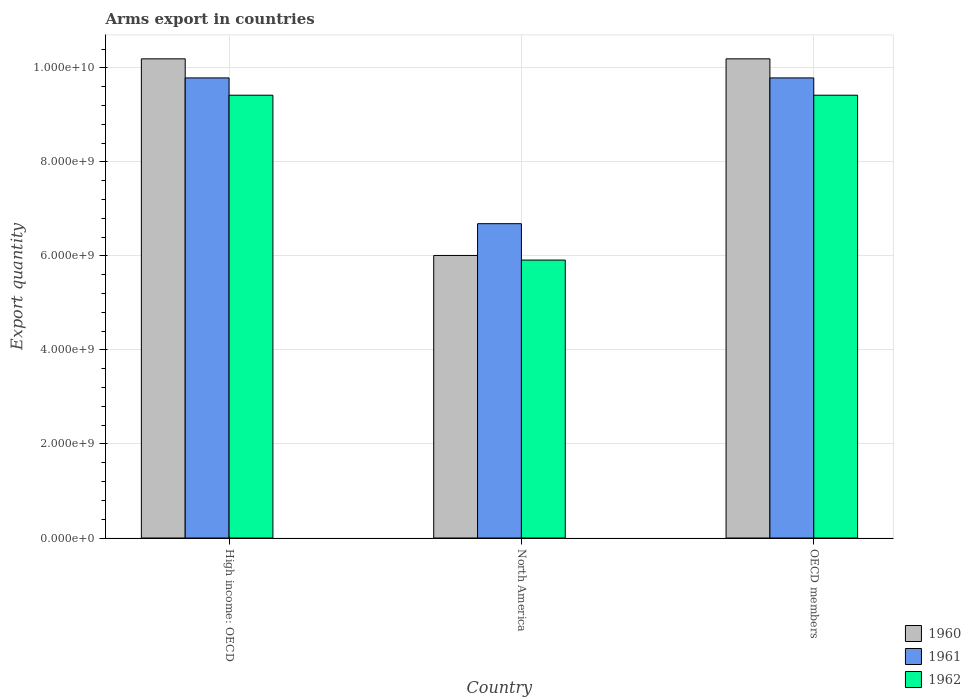How many different coloured bars are there?
Provide a succinct answer. 3. Are the number of bars per tick equal to the number of legend labels?
Your answer should be compact. Yes. How many bars are there on the 1st tick from the left?
Keep it short and to the point. 3. In how many cases, is the number of bars for a given country not equal to the number of legend labels?
Offer a terse response. 0. What is the total arms export in 1960 in OECD members?
Give a very brief answer. 1.02e+1. Across all countries, what is the maximum total arms export in 1961?
Make the answer very short. 9.79e+09. Across all countries, what is the minimum total arms export in 1962?
Keep it short and to the point. 5.91e+09. In which country was the total arms export in 1960 maximum?
Give a very brief answer. High income: OECD. In which country was the total arms export in 1960 minimum?
Your answer should be compact. North America. What is the total total arms export in 1961 in the graph?
Offer a terse response. 2.63e+1. What is the difference between the total arms export in 1960 in High income: OECD and that in North America?
Keep it short and to the point. 4.18e+09. What is the difference between the total arms export in 1961 in North America and the total arms export in 1962 in High income: OECD?
Your answer should be compact. -2.73e+09. What is the average total arms export in 1960 per country?
Provide a short and direct response. 8.80e+09. What is the difference between the total arms export of/in 1961 and total arms export of/in 1960 in North America?
Your answer should be compact. 6.76e+08. What is the ratio of the total arms export in 1960 in High income: OECD to that in North America?
Provide a short and direct response. 1.7. Is the total arms export in 1960 in High income: OECD less than that in OECD members?
Make the answer very short. No. What is the difference between the highest and the second highest total arms export in 1962?
Your response must be concise. 3.51e+09. What is the difference between the highest and the lowest total arms export in 1960?
Make the answer very short. 4.18e+09. Is the sum of the total arms export in 1961 in High income: OECD and North America greater than the maximum total arms export in 1960 across all countries?
Offer a terse response. Yes. What does the 2nd bar from the left in High income: OECD represents?
Give a very brief answer. 1961. What does the 2nd bar from the right in OECD members represents?
Ensure brevity in your answer.  1961. Is it the case that in every country, the sum of the total arms export in 1962 and total arms export in 1961 is greater than the total arms export in 1960?
Provide a short and direct response. Yes. How many bars are there?
Provide a short and direct response. 9. Are all the bars in the graph horizontal?
Ensure brevity in your answer.  No. Are the values on the major ticks of Y-axis written in scientific E-notation?
Keep it short and to the point. Yes. Does the graph contain any zero values?
Your answer should be very brief. No. How many legend labels are there?
Offer a terse response. 3. How are the legend labels stacked?
Make the answer very short. Vertical. What is the title of the graph?
Your response must be concise. Arms export in countries. Does "1963" appear as one of the legend labels in the graph?
Make the answer very short. No. What is the label or title of the X-axis?
Provide a short and direct response. Country. What is the label or title of the Y-axis?
Ensure brevity in your answer.  Export quantity. What is the Export quantity in 1960 in High income: OECD?
Your answer should be very brief. 1.02e+1. What is the Export quantity of 1961 in High income: OECD?
Offer a very short reply. 9.79e+09. What is the Export quantity of 1962 in High income: OECD?
Provide a succinct answer. 9.42e+09. What is the Export quantity of 1960 in North America?
Provide a short and direct response. 6.01e+09. What is the Export quantity in 1961 in North America?
Make the answer very short. 6.69e+09. What is the Export quantity of 1962 in North America?
Offer a very short reply. 5.91e+09. What is the Export quantity of 1960 in OECD members?
Your answer should be very brief. 1.02e+1. What is the Export quantity of 1961 in OECD members?
Provide a short and direct response. 9.79e+09. What is the Export quantity of 1962 in OECD members?
Give a very brief answer. 9.42e+09. Across all countries, what is the maximum Export quantity in 1960?
Provide a short and direct response. 1.02e+1. Across all countries, what is the maximum Export quantity of 1961?
Offer a terse response. 9.79e+09. Across all countries, what is the maximum Export quantity of 1962?
Make the answer very short. 9.42e+09. Across all countries, what is the minimum Export quantity of 1960?
Your response must be concise. 6.01e+09. Across all countries, what is the minimum Export quantity of 1961?
Your answer should be very brief. 6.69e+09. Across all countries, what is the minimum Export quantity in 1962?
Offer a terse response. 5.91e+09. What is the total Export quantity in 1960 in the graph?
Make the answer very short. 2.64e+1. What is the total Export quantity in 1961 in the graph?
Keep it short and to the point. 2.63e+1. What is the total Export quantity in 1962 in the graph?
Provide a succinct answer. 2.48e+1. What is the difference between the Export quantity in 1960 in High income: OECD and that in North America?
Provide a short and direct response. 4.18e+09. What is the difference between the Export quantity in 1961 in High income: OECD and that in North America?
Offer a very short reply. 3.10e+09. What is the difference between the Export quantity in 1962 in High income: OECD and that in North America?
Offer a very short reply. 3.51e+09. What is the difference between the Export quantity of 1961 in High income: OECD and that in OECD members?
Your answer should be compact. 0. What is the difference between the Export quantity in 1962 in High income: OECD and that in OECD members?
Keep it short and to the point. 0. What is the difference between the Export quantity in 1960 in North America and that in OECD members?
Provide a short and direct response. -4.18e+09. What is the difference between the Export quantity of 1961 in North America and that in OECD members?
Ensure brevity in your answer.  -3.10e+09. What is the difference between the Export quantity of 1962 in North America and that in OECD members?
Your answer should be very brief. -3.51e+09. What is the difference between the Export quantity in 1960 in High income: OECD and the Export quantity in 1961 in North America?
Provide a succinct answer. 3.51e+09. What is the difference between the Export quantity of 1960 in High income: OECD and the Export quantity of 1962 in North America?
Provide a short and direct response. 4.28e+09. What is the difference between the Export quantity of 1961 in High income: OECD and the Export quantity of 1962 in North America?
Keep it short and to the point. 3.88e+09. What is the difference between the Export quantity of 1960 in High income: OECD and the Export quantity of 1961 in OECD members?
Your response must be concise. 4.06e+08. What is the difference between the Export quantity of 1960 in High income: OECD and the Export quantity of 1962 in OECD members?
Keep it short and to the point. 7.74e+08. What is the difference between the Export quantity in 1961 in High income: OECD and the Export quantity in 1962 in OECD members?
Provide a short and direct response. 3.68e+08. What is the difference between the Export quantity in 1960 in North America and the Export quantity in 1961 in OECD members?
Make the answer very short. -3.78e+09. What is the difference between the Export quantity of 1960 in North America and the Export quantity of 1962 in OECD members?
Make the answer very short. -3.41e+09. What is the difference between the Export quantity in 1961 in North America and the Export quantity in 1962 in OECD members?
Your answer should be compact. -2.73e+09. What is the average Export quantity of 1960 per country?
Your response must be concise. 8.80e+09. What is the average Export quantity of 1961 per country?
Give a very brief answer. 8.75e+09. What is the average Export quantity of 1962 per country?
Provide a short and direct response. 8.25e+09. What is the difference between the Export quantity in 1960 and Export quantity in 1961 in High income: OECD?
Your answer should be compact. 4.06e+08. What is the difference between the Export quantity in 1960 and Export quantity in 1962 in High income: OECD?
Make the answer very short. 7.74e+08. What is the difference between the Export quantity in 1961 and Export quantity in 1962 in High income: OECD?
Your response must be concise. 3.68e+08. What is the difference between the Export quantity in 1960 and Export quantity in 1961 in North America?
Provide a short and direct response. -6.76e+08. What is the difference between the Export quantity in 1960 and Export quantity in 1962 in North America?
Your answer should be compact. 9.80e+07. What is the difference between the Export quantity in 1961 and Export quantity in 1962 in North America?
Keep it short and to the point. 7.74e+08. What is the difference between the Export quantity in 1960 and Export quantity in 1961 in OECD members?
Offer a terse response. 4.06e+08. What is the difference between the Export quantity of 1960 and Export quantity of 1962 in OECD members?
Offer a very short reply. 7.74e+08. What is the difference between the Export quantity of 1961 and Export quantity of 1962 in OECD members?
Offer a terse response. 3.68e+08. What is the ratio of the Export quantity of 1960 in High income: OECD to that in North America?
Provide a succinct answer. 1.7. What is the ratio of the Export quantity of 1961 in High income: OECD to that in North America?
Ensure brevity in your answer.  1.46. What is the ratio of the Export quantity in 1962 in High income: OECD to that in North America?
Provide a short and direct response. 1.59. What is the ratio of the Export quantity of 1960 in North America to that in OECD members?
Give a very brief answer. 0.59. What is the ratio of the Export quantity in 1961 in North America to that in OECD members?
Offer a terse response. 0.68. What is the ratio of the Export quantity of 1962 in North America to that in OECD members?
Give a very brief answer. 0.63. What is the difference between the highest and the second highest Export quantity of 1961?
Provide a succinct answer. 0. What is the difference between the highest and the second highest Export quantity of 1962?
Offer a very short reply. 0. What is the difference between the highest and the lowest Export quantity in 1960?
Ensure brevity in your answer.  4.18e+09. What is the difference between the highest and the lowest Export quantity of 1961?
Offer a terse response. 3.10e+09. What is the difference between the highest and the lowest Export quantity of 1962?
Keep it short and to the point. 3.51e+09. 